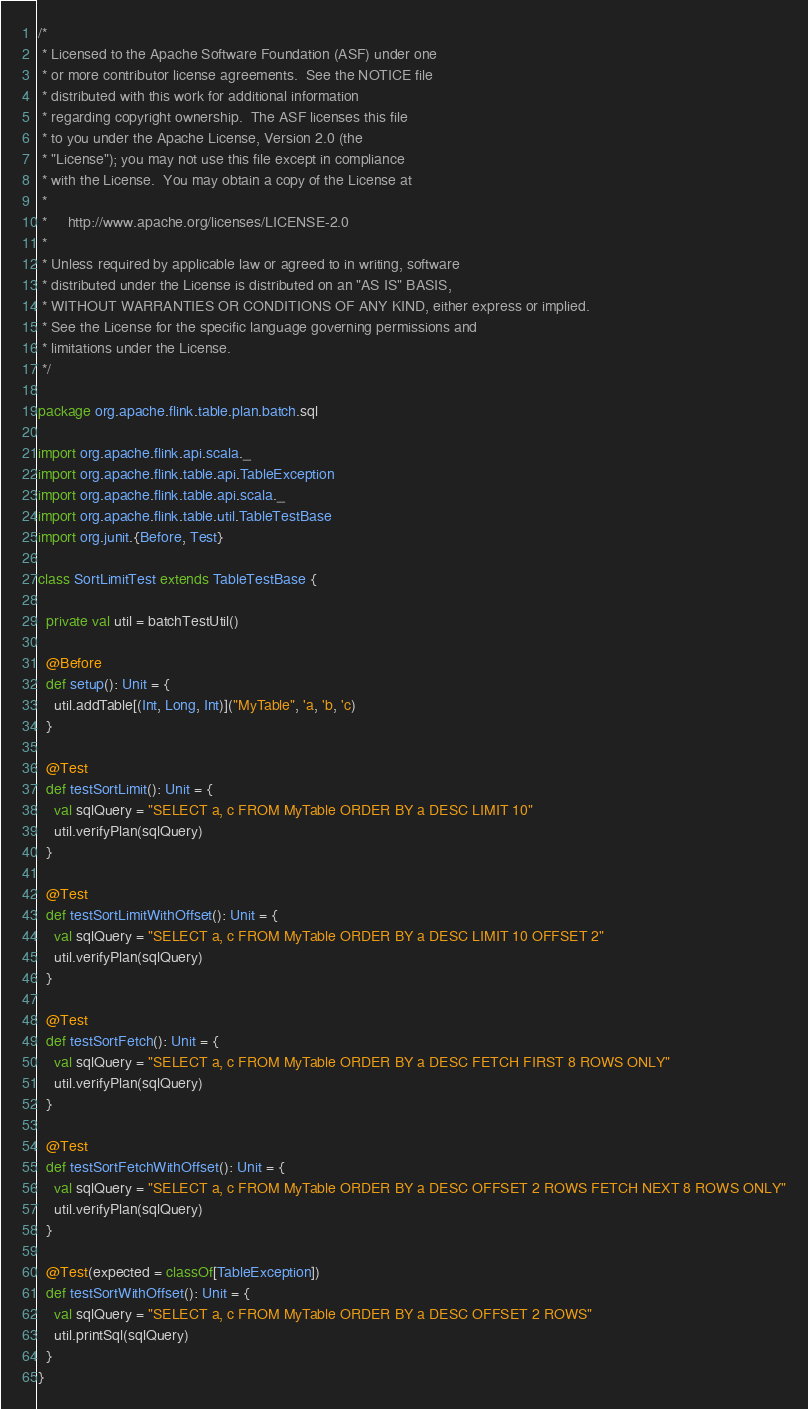Convert code to text. <code><loc_0><loc_0><loc_500><loc_500><_Scala_>/*
 * Licensed to the Apache Software Foundation (ASF) under one
 * or more contributor license agreements.  See the NOTICE file
 * distributed with this work for additional information
 * regarding copyright ownership.  The ASF licenses this file
 * to you under the Apache License, Version 2.0 (the
 * "License"); you may not use this file except in compliance
 * with the License.  You may obtain a copy of the License at
 *
 *     http://www.apache.org/licenses/LICENSE-2.0
 *
 * Unless required by applicable law or agreed to in writing, software
 * distributed under the License is distributed on an "AS IS" BASIS,
 * WITHOUT WARRANTIES OR CONDITIONS OF ANY KIND, either express or implied.
 * See the License for the specific language governing permissions and
 * limitations under the License.
 */

package org.apache.flink.table.plan.batch.sql

import org.apache.flink.api.scala._
import org.apache.flink.table.api.TableException
import org.apache.flink.table.api.scala._
import org.apache.flink.table.util.TableTestBase
import org.junit.{Before, Test}

class SortLimitTest extends TableTestBase {

  private val util = batchTestUtil()

  @Before
  def setup(): Unit = {
    util.addTable[(Int, Long, Int)]("MyTable", 'a, 'b, 'c)
  }

  @Test
  def testSortLimit(): Unit = {
    val sqlQuery = "SELECT a, c FROM MyTable ORDER BY a DESC LIMIT 10"
    util.verifyPlan(sqlQuery)
  }

  @Test
  def testSortLimitWithOffset(): Unit = {
    val sqlQuery = "SELECT a, c FROM MyTable ORDER BY a DESC LIMIT 10 OFFSET 2"
    util.verifyPlan(sqlQuery)
  }

  @Test
  def testSortFetch(): Unit = {
    val sqlQuery = "SELECT a, c FROM MyTable ORDER BY a DESC FETCH FIRST 8 ROWS ONLY"
    util.verifyPlan(sqlQuery)
  }

  @Test
  def testSortFetchWithOffset(): Unit = {
    val sqlQuery = "SELECT a, c FROM MyTable ORDER BY a DESC OFFSET 2 ROWS FETCH NEXT 8 ROWS ONLY"
    util.verifyPlan(sqlQuery)
  }

  @Test(expected = classOf[TableException])
  def testSortWithOffset(): Unit = {
    val sqlQuery = "SELECT a, c FROM MyTable ORDER BY a DESC OFFSET 2 ROWS"
    util.printSql(sqlQuery)
  }
}
</code> 